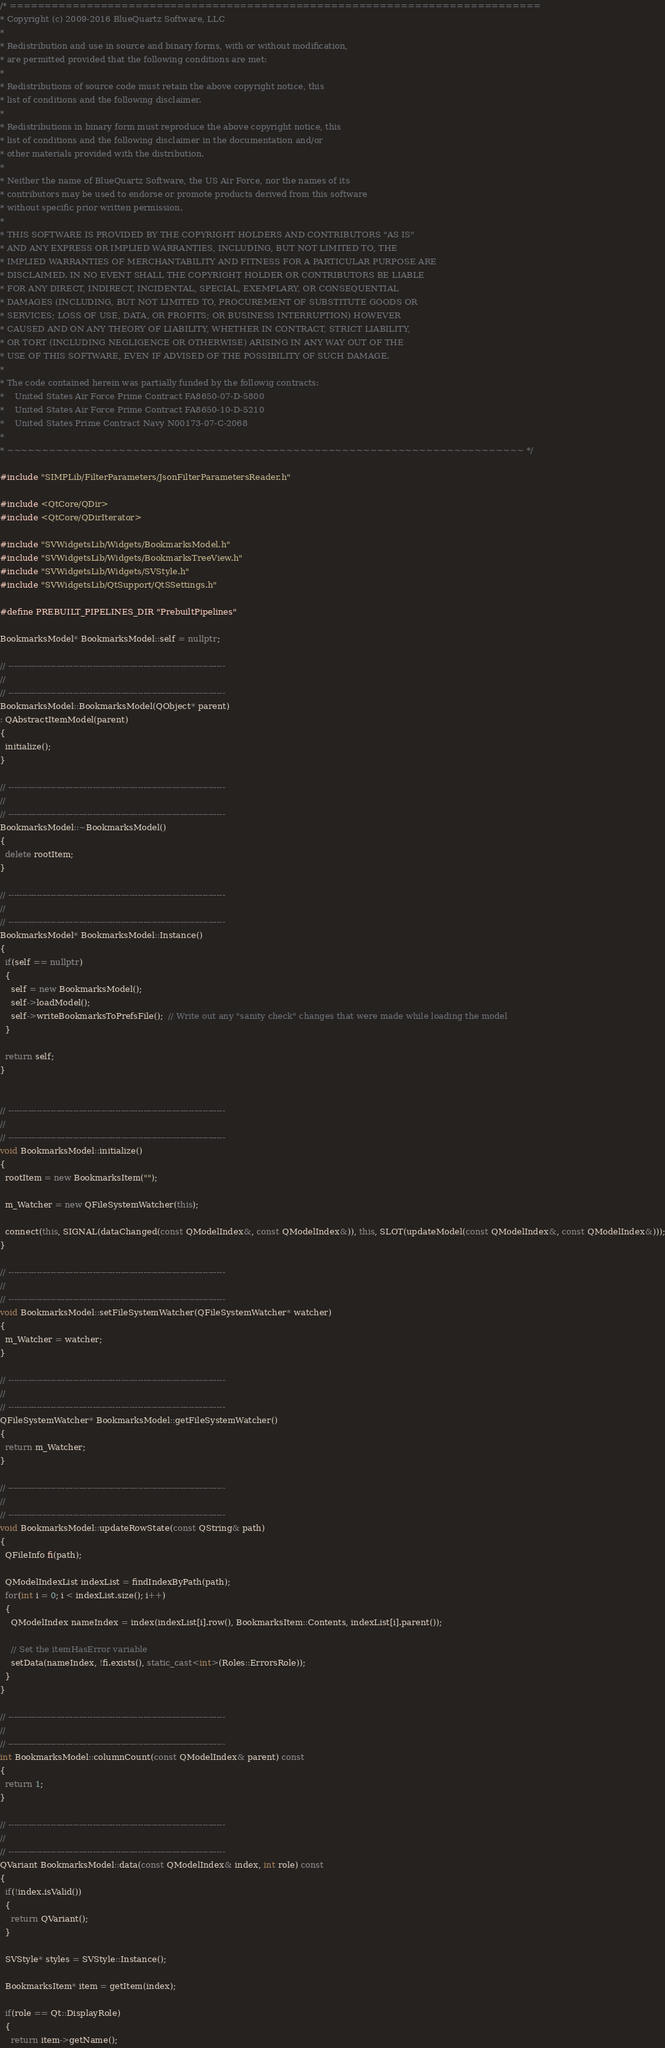<code> <loc_0><loc_0><loc_500><loc_500><_C++_>/* ============================================================================
* Copyright (c) 2009-2016 BlueQuartz Software, LLC
*
* Redistribution and use in source and binary forms, with or without modification,
* are permitted provided that the following conditions are met:
*
* Redistributions of source code must retain the above copyright notice, this
* list of conditions and the following disclaimer.
*
* Redistributions in binary form must reproduce the above copyright notice, this
* list of conditions and the following disclaimer in the documentation and/or
* other materials provided with the distribution.
*
* Neither the name of BlueQuartz Software, the US Air Force, nor the names of its
* contributors may be used to endorse or promote products derived from this software
* without specific prior written permission.
*
* THIS SOFTWARE IS PROVIDED BY THE COPYRIGHT HOLDERS AND CONTRIBUTORS "AS IS"
* AND ANY EXPRESS OR IMPLIED WARRANTIES, INCLUDING, BUT NOT LIMITED TO, THE
* IMPLIED WARRANTIES OF MERCHANTABILITY AND FITNESS FOR A PARTICULAR PURPOSE ARE
* DISCLAIMED. IN NO EVENT SHALL THE COPYRIGHT HOLDER OR CONTRIBUTORS BE LIABLE
* FOR ANY DIRECT, INDIRECT, INCIDENTAL, SPECIAL, EXEMPLARY, OR CONSEQUENTIAL
* DAMAGES (INCLUDING, BUT NOT LIMITED TO, PROCUREMENT OF SUBSTITUTE GOODS OR
* SERVICES; LOSS OF USE, DATA, OR PROFITS; OR BUSINESS INTERRUPTION) HOWEVER
* CAUSED AND ON ANY THEORY OF LIABILITY, WHETHER IN CONTRACT, STRICT LIABILITY,
* OR TORT (INCLUDING NEGLIGENCE OR OTHERWISE) ARISING IN ANY WAY OUT OF THE
* USE OF THIS SOFTWARE, EVEN IF ADVISED OF THE POSSIBILITY OF SUCH DAMAGE.
*
* The code contained herein was partially funded by the followig contracts:
*    United States Air Force Prime Contract FA8650-07-D-5800
*    United States Air Force Prime Contract FA8650-10-D-5210
*    United States Prime Contract Navy N00173-07-C-2068
*
* ~~~~~~~~~~~~~~~~~~~~~~~~~~~~~~~~~~~~~~~~~~~~~~~~~~~~~~~~~~~~~~~~~~~~~~~~~~ */

#include "SIMPLib/FilterParameters/JsonFilterParametersReader.h"

#include <QtCore/QDir>
#include <QtCore/QDirIterator>

#include "SVWidgetsLib/Widgets/BookmarksModel.h"
#include "SVWidgetsLib/Widgets/BookmarksTreeView.h"
#include "SVWidgetsLib/Widgets/SVStyle.h"
#include "SVWidgetsLib/QtSupport/QtSSettings.h"

#define PREBUILT_PIPELINES_DIR "PrebuiltPipelines"

BookmarksModel* BookmarksModel::self = nullptr;

// -----------------------------------------------------------------------------
//
// -----------------------------------------------------------------------------
BookmarksModel::BookmarksModel(QObject* parent)
: QAbstractItemModel(parent)
{
  initialize();
}

// -----------------------------------------------------------------------------
//
// -----------------------------------------------------------------------------
BookmarksModel::~BookmarksModel()
{
  delete rootItem;
}

// -----------------------------------------------------------------------------
//
// -----------------------------------------------------------------------------
BookmarksModel* BookmarksModel::Instance()
{
  if(self == nullptr)
  {
    self = new BookmarksModel();
    self->loadModel();
    self->writeBookmarksToPrefsFile();  // Write out any "sanity check" changes that were made while loading the model
  }

  return self;
}


// -----------------------------------------------------------------------------
//
// -----------------------------------------------------------------------------
void BookmarksModel::initialize()
{
  rootItem = new BookmarksItem("");

  m_Watcher = new QFileSystemWatcher(this);

  connect(this, SIGNAL(dataChanged(const QModelIndex&, const QModelIndex&)), this, SLOT(updateModel(const QModelIndex&, const QModelIndex&)));
}

// -----------------------------------------------------------------------------
//
// -----------------------------------------------------------------------------
void BookmarksModel::setFileSystemWatcher(QFileSystemWatcher* watcher)
{
  m_Watcher = watcher;
}

// -----------------------------------------------------------------------------
//
// -----------------------------------------------------------------------------
QFileSystemWatcher* BookmarksModel::getFileSystemWatcher()
{
  return m_Watcher;
}

// -----------------------------------------------------------------------------
//
// -----------------------------------------------------------------------------
void BookmarksModel::updateRowState(const QString& path)
{
  QFileInfo fi(path);

  QModelIndexList indexList = findIndexByPath(path);
  for(int i = 0; i < indexList.size(); i++)
  {
    QModelIndex nameIndex = index(indexList[i].row(), BookmarksItem::Contents, indexList[i].parent());

    // Set the itemHasError variable
    setData(nameIndex, !fi.exists(), static_cast<int>(Roles::ErrorsRole));
  }
}

// -----------------------------------------------------------------------------
//
// -----------------------------------------------------------------------------
int BookmarksModel::columnCount(const QModelIndex& parent) const
{
  return 1;
}

// -----------------------------------------------------------------------------
//
// -----------------------------------------------------------------------------
QVariant BookmarksModel::data(const QModelIndex& index, int role) const
{
  if(!index.isValid())
  {
    return QVariant();
  }

  SVStyle* styles = SVStyle::Instance();

  BookmarksItem* item = getItem(index);

  if(role == Qt::DisplayRole)
  {
    return item->getName();</code> 